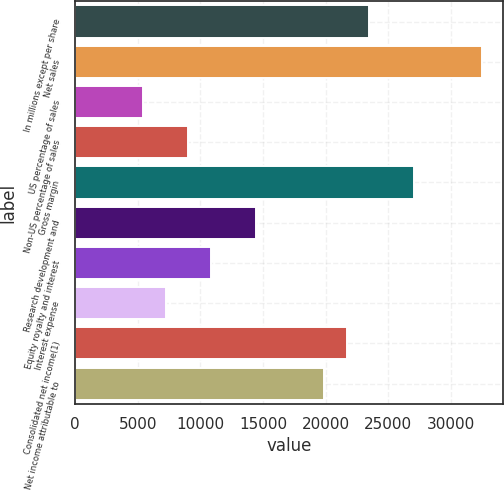Convert chart to OTSL. <chart><loc_0><loc_0><loc_500><loc_500><bar_chart><fcel>In millions except per share<fcel>Net sales<fcel>US percentage of sales<fcel>Non-US percentage of sales<fcel>Gross margin<fcel>Research development and<fcel>Equity royalty and interest<fcel>Interest expense<fcel>Consolidated net income(1)<fcel>Net income attributable to<nl><fcel>23462<fcel>32485.4<fcel>5415.33<fcel>9024.67<fcel>27071.4<fcel>14438.7<fcel>10829.3<fcel>7220<fcel>21657.4<fcel>19852.7<nl></chart> 